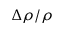Convert formula to latex. <formula><loc_0><loc_0><loc_500><loc_500>\Delta \rho / \rho</formula> 